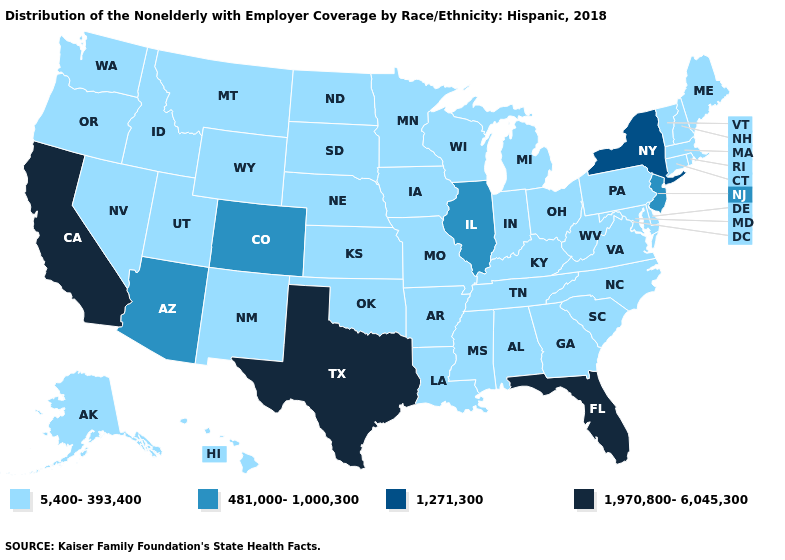What is the value of New Mexico?
Concise answer only. 5,400-393,400. Does the map have missing data?
Concise answer only. No. Does Kansas have a lower value than Arkansas?
Keep it brief. No. What is the value of Arkansas?
Concise answer only. 5,400-393,400. Name the states that have a value in the range 481,000-1,000,300?
Answer briefly. Arizona, Colorado, Illinois, New Jersey. Name the states that have a value in the range 1,970,800-6,045,300?
Give a very brief answer. California, Florida, Texas. Among the states that border California , which have the lowest value?
Write a very short answer. Nevada, Oregon. Which states have the highest value in the USA?
Quick response, please. California, Florida, Texas. What is the value of Michigan?
Write a very short answer. 5,400-393,400. How many symbols are there in the legend?
Concise answer only. 4. Name the states that have a value in the range 481,000-1,000,300?
Give a very brief answer. Arizona, Colorado, Illinois, New Jersey. What is the highest value in states that border West Virginia?
Concise answer only. 5,400-393,400. Is the legend a continuous bar?
Give a very brief answer. No. Name the states that have a value in the range 1,970,800-6,045,300?
Quick response, please. California, Florida, Texas. 